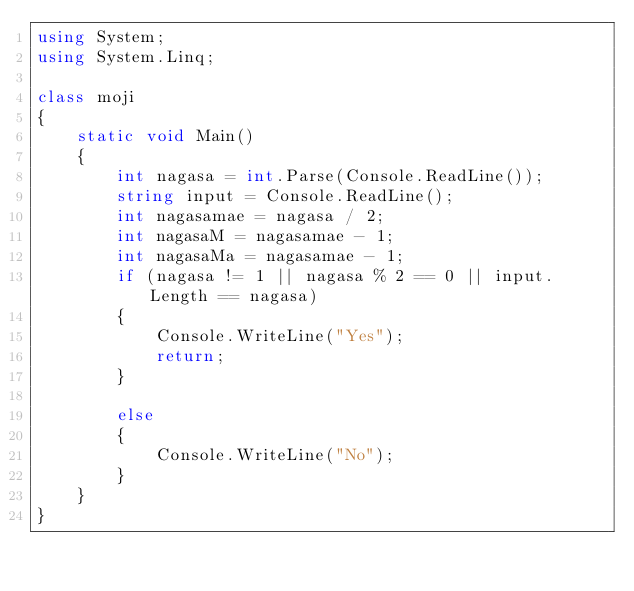<code> <loc_0><loc_0><loc_500><loc_500><_C#_>using System;
using System.Linq;

class moji
{
    static void Main()
    {
        int nagasa = int.Parse(Console.ReadLine());
        string input = Console.ReadLine();
        int nagasamae = nagasa / 2;
        int nagasaM = nagasamae - 1;
        int nagasaMa = nagasamae - 1;
        if (nagasa != 1 || nagasa % 2 == 0 || input.Length == nagasa)
        {
            Console.WriteLine("Yes");
            return;
        }
        
        else
        {
            Console.WriteLine("No");
        }
    }
}
</code> 